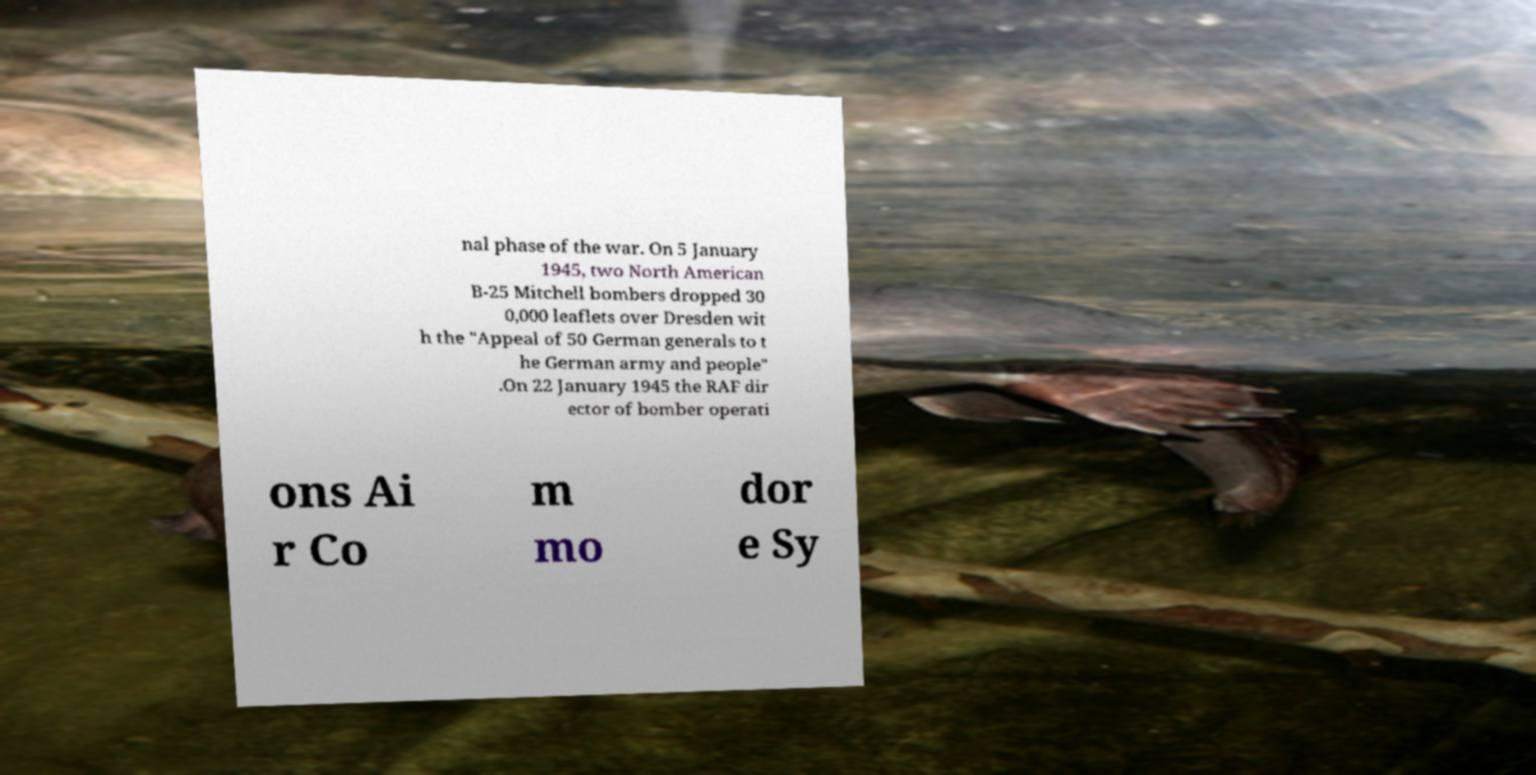I need the written content from this picture converted into text. Can you do that? nal phase of the war. On 5 January 1945, two North American B-25 Mitchell bombers dropped 30 0,000 leaflets over Dresden wit h the "Appeal of 50 German generals to t he German army and people" .On 22 January 1945 the RAF dir ector of bomber operati ons Ai r Co m mo dor e Sy 